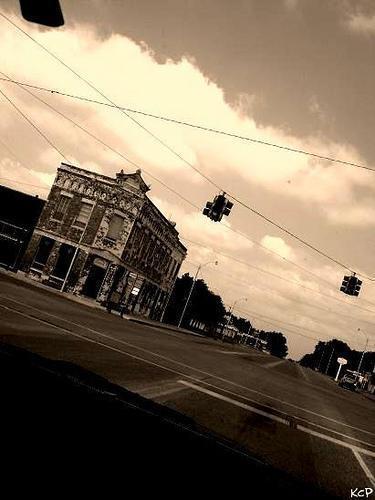How many people are in the water?
Give a very brief answer. 0. 